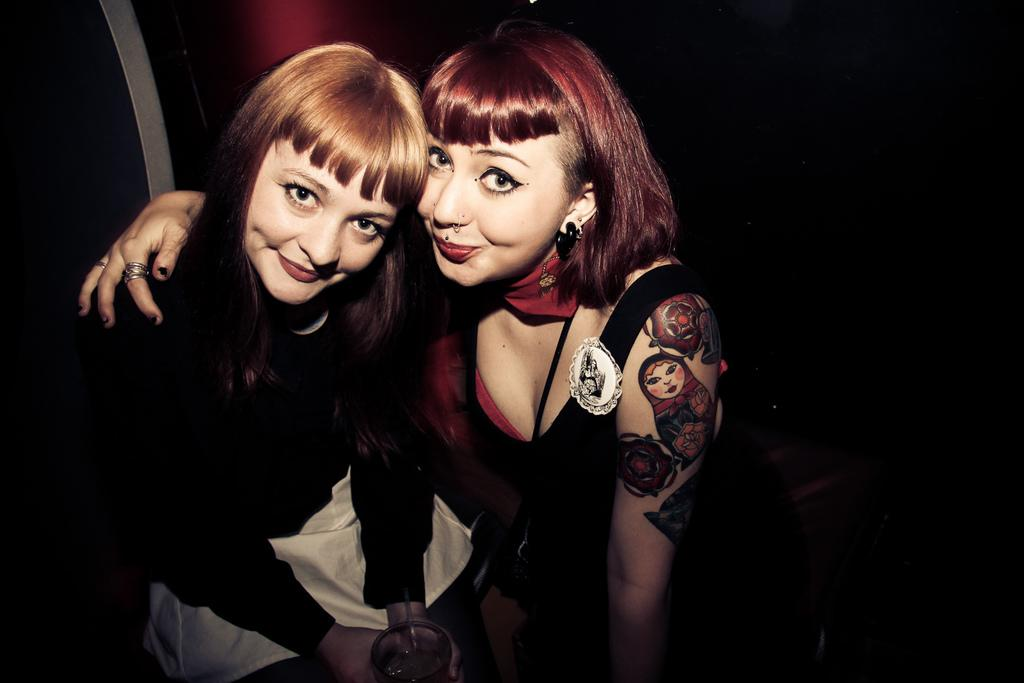How many people are in the image? There are two girls in the image. What are the girls doing in the image? The girls are sitting. What is one of the girls holding? One of the girls is holding a glass. What can be observed about the background of the image? The background of the image is dark. What type of dogs can be seen walking in the image? There are no dogs present in the image. What word is being spoken by one of the girls in the image? The image does not provide any information about spoken words. 